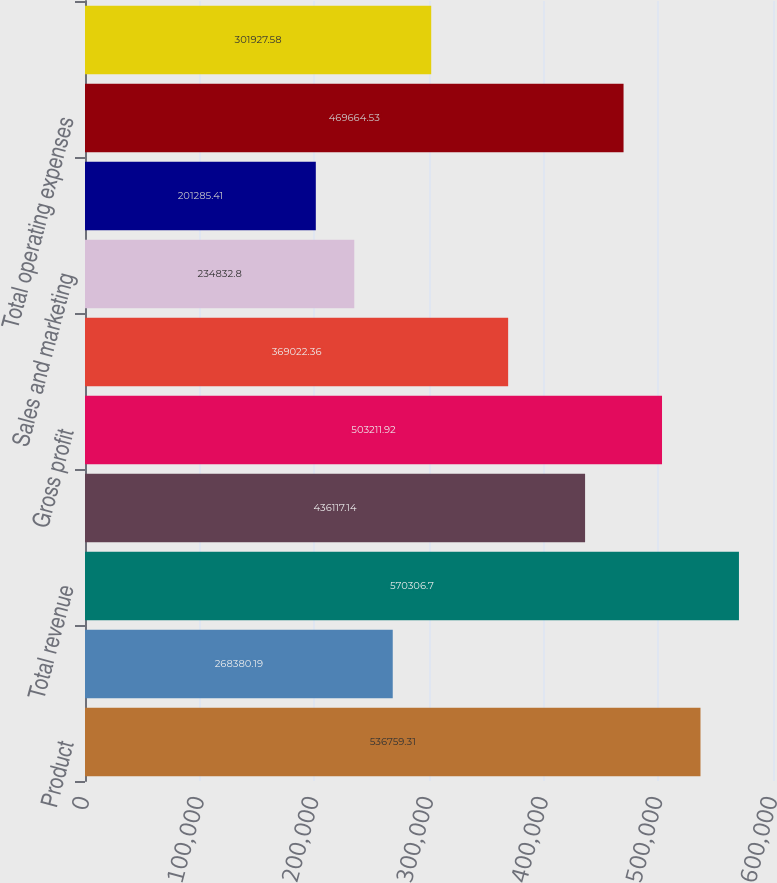<chart> <loc_0><loc_0><loc_500><loc_500><bar_chart><fcel>Product<fcel>Service<fcel>Total revenue<fcel>Total cost of revenue<fcel>Gross profit<fcel>Research and development<fcel>Sales and marketing<fcel>General and administrative<fcel>Total operating expenses<fcel>Income from operations<nl><fcel>536759<fcel>268380<fcel>570307<fcel>436117<fcel>503212<fcel>369022<fcel>234833<fcel>201285<fcel>469665<fcel>301928<nl></chart> 